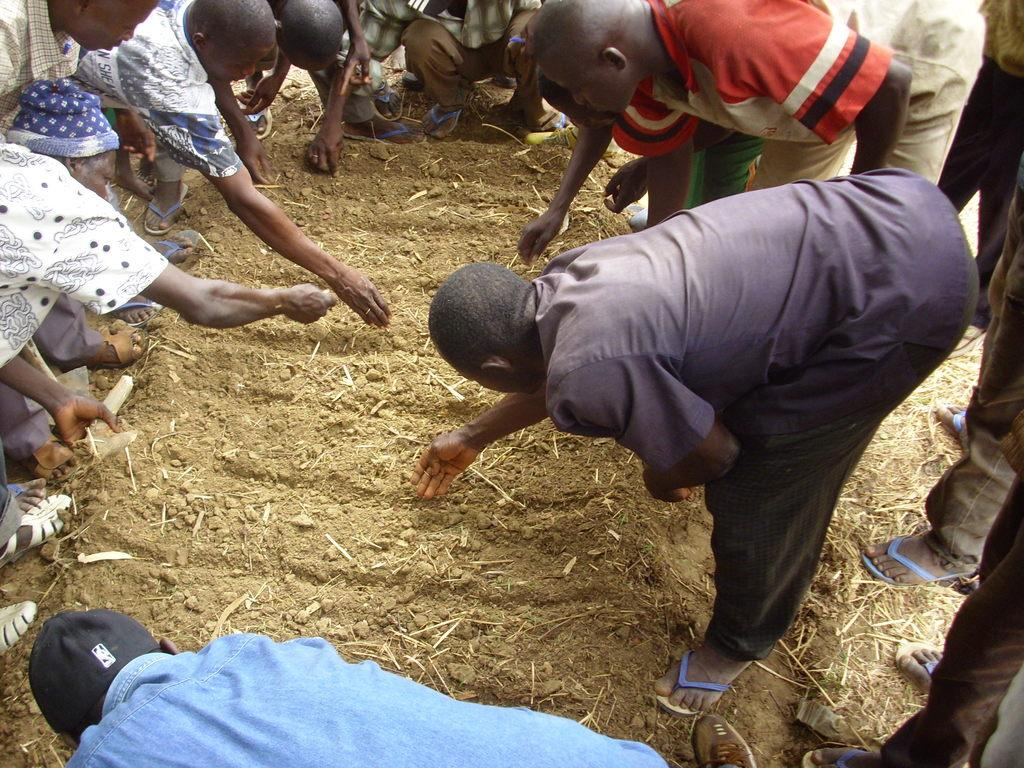What is the main subject of the image? The main subject of the image is a crowd of people. Where are the people located in the image? The people are visible on the ground. What type of trouble can be heard in the voice of the person in the image? There is no person or voice present in the image; it only shows a crowd of people. 